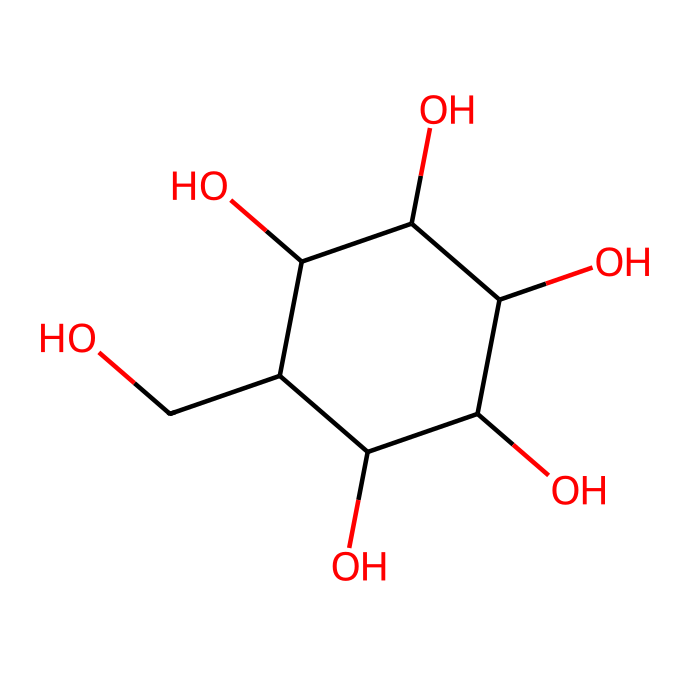how many carbon atoms are in glucose? The SMILES representation indicates that the structure has multiple carbon atoms. By analyzing the representation, we can see the 'C' symbols indicating carbon atoms. Counting them reveals that there are six 'C's in total.
Answer: six how many hydroxyl (OH) groups are present? In the chemical structure, each 'O' that is bonded to a carbon can indicate a hydroxyl group. By identifying all the 'O's in the structure, we see that there are five instances where a hydroxyl group (OH) is formed.
Answer: five what is the molecular formula for glucose? By determining the number of carbon (C), hydrogen (H), and oxygen (O) atoms from the structure, we have 6 carbon atoms, 12 hydrogen atoms, and 6 oxygen atoms, which gives us the molecular formula C6H12O6.
Answer: C6H12O6 is glucose a polar substance? The arrangement of hydroxyl groups in the structure, combined with the presence of multiple polar O-H bonds, indicates that glucose has a polar nature. Thus, glucose would be soluble in water and behaves as a polar substance.
Answer: yes what type of compound is glucose classified as? Given the structure, glucose is a sugar molecule with multiple hydroxyl (OH) groups, classifying it as a carbohydrate, which is a specific type of non-electrolyte compound.
Answer: carbohydrate how does glucose contribute to energy? The chemical structure has multiple hydroxyl groups and can undergo biochemical processes such as glycolysis, where it is broken down in cells to release energy, indicating its role in energy metabolism.
Answer: energy source what characteristic makes glucose a non-electrolyte? The absence of ionic bonds or the formation of ions in an aqueous solution illustrates that glucose does not dissociate in water, which is a defining characteristic of non-electrolytes.
Answer: no ionization 